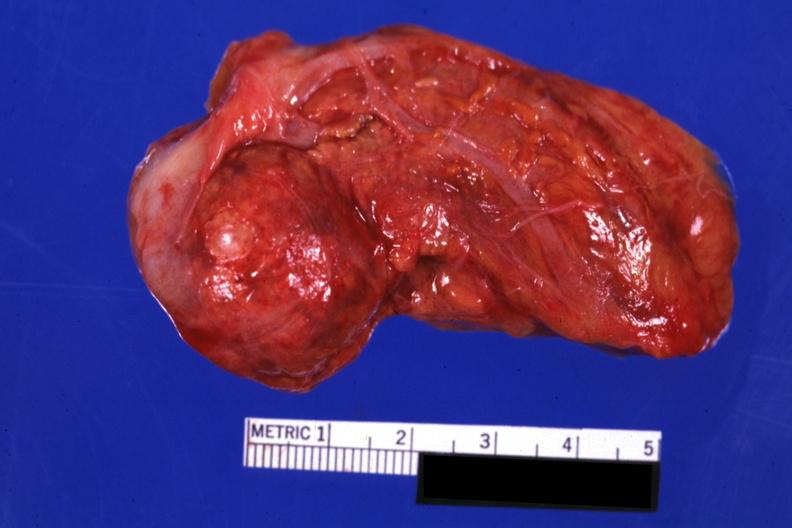s adrenal present?
Answer the question using a single word or phrase. Yes 